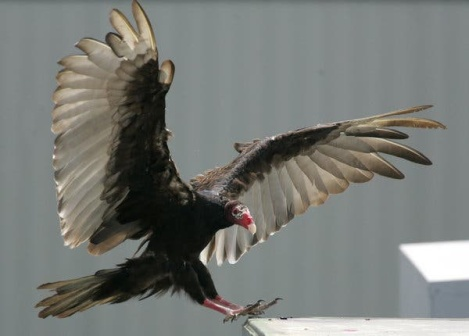What do you see happening in this image? The image captures a turkey vulture as it is in mid-flight, preparing to land. Seen from the side, the vulture's wings are spread wide, displaying a mix of black and brown colors with white tips. The striking red head with a white beak is turned towards the camera. The bird soars above a gray building with a white roof, set against the backdrop of a clear blue sky. This setting highlights the freedom and vastness of the vulture's flight. Its position, relative to the building, indicates that it is flying at a significant height. The scene doesn't depict any imaginary elements; everything is based on observable details. 